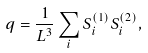<formula> <loc_0><loc_0><loc_500><loc_500>q = \frac { 1 } { L ^ { 3 } } \sum _ { i } S _ { i } ^ { ( 1 ) } S _ { i } ^ { ( 2 ) } ,</formula> 